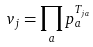<formula> <loc_0><loc_0><loc_500><loc_500>v _ { j } = \prod _ { a } p _ { a } ^ { T _ { j a } }</formula> 